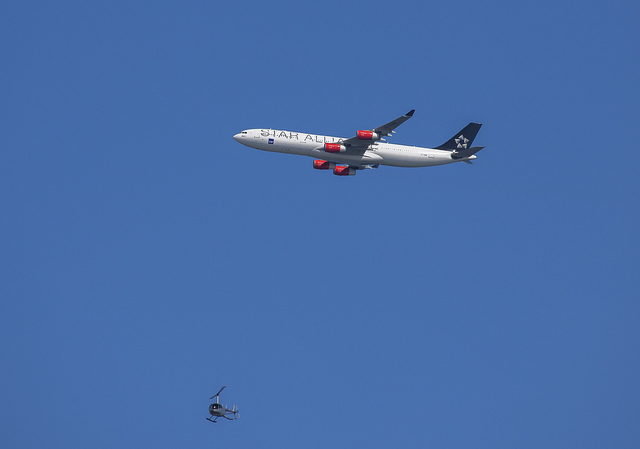Identify the text contained in this image. STAR ALLIA 